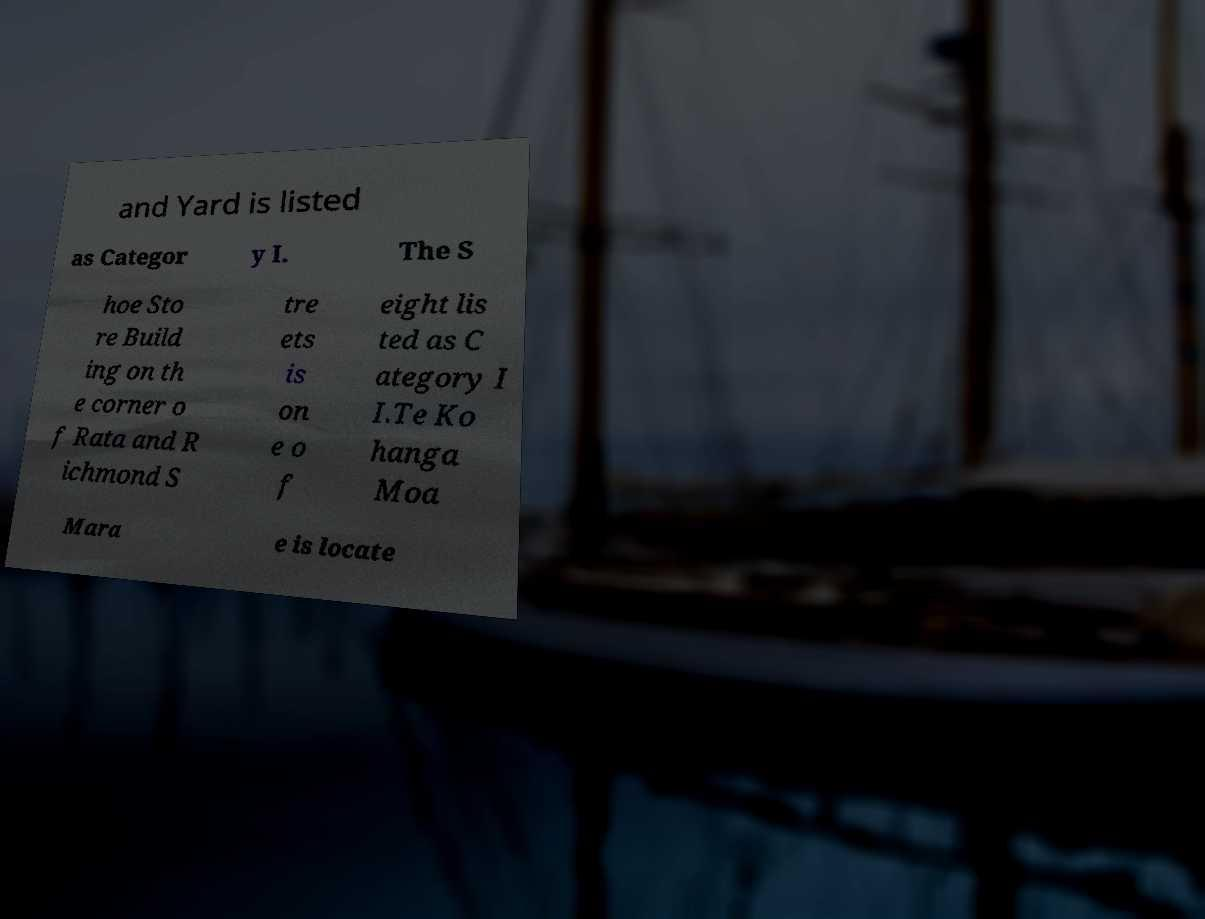Can you accurately transcribe the text from the provided image for me? and Yard is listed as Categor y I. The S hoe Sto re Build ing on th e corner o f Rata and R ichmond S tre ets is on e o f eight lis ted as C ategory I I.Te Ko hanga Moa Mara e is locate 